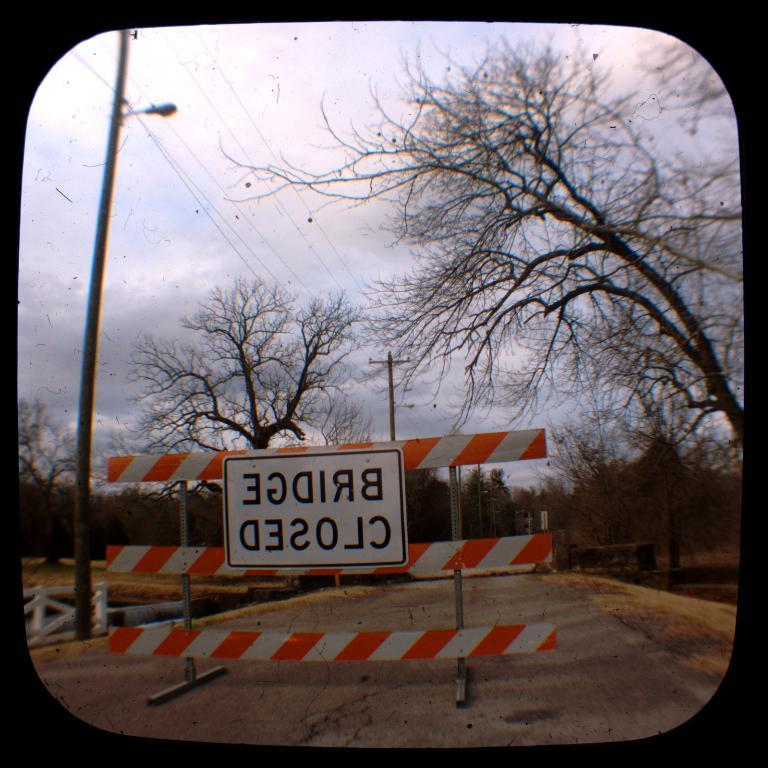What is the main subject of the image? The image is a view from a window. What can be seen outside the window? There are trees visible in the image. What else is present in the image? There are poles, cables, and a light attached to one of the poles. What is visible in the background of the image? The sky is visible in the image. How much profit does the tree generate in the image? There is no indication of profit in the image, as it is a view from a window with trees and other objects. What type of thumb can be seen interacting with the light in the image? There is no thumb present in the image; it features a view from a window with trees, poles, cables, and a light. 